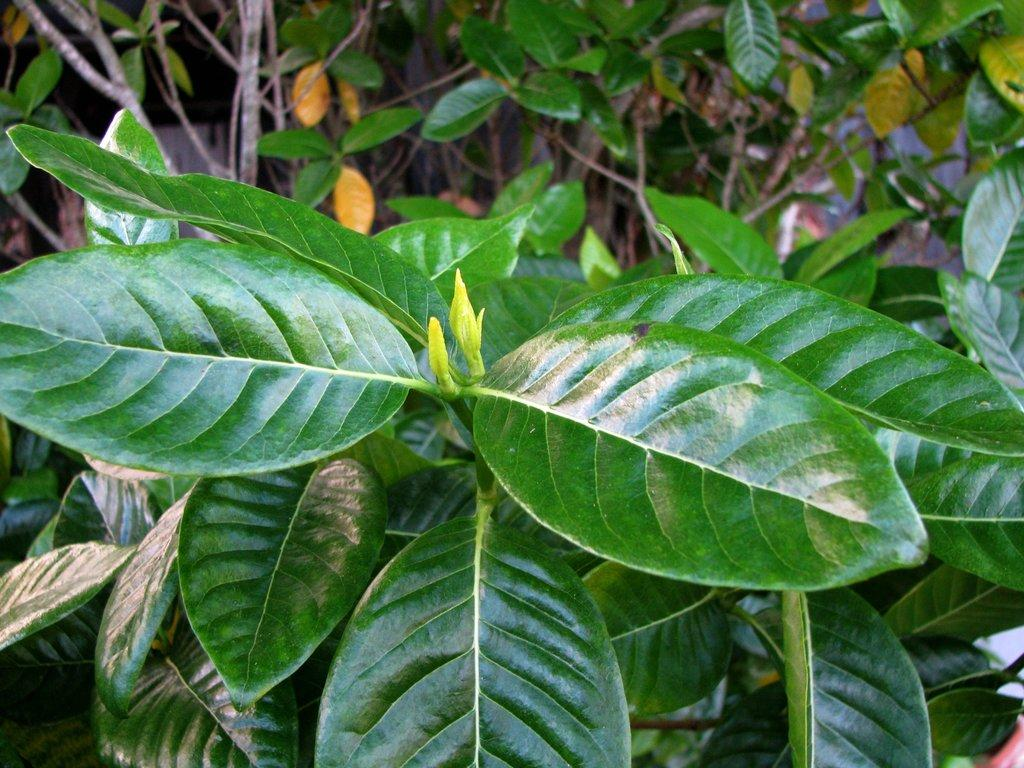What type of plant is visible in the image? There is a green leaf plant in the image. What type of boats can be seen sailing in the image? There are no boats present in the image; it features a green leaf plant. What type of weather can be observed in the image? The image does not provide any information about the weather, as it only shows a green leaf plant. 